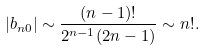Convert formula to latex. <formula><loc_0><loc_0><loc_500><loc_500>| b _ { n 0 } | \sim \frac { ( n - 1 ) ! } { 2 ^ { n - 1 } ( 2 n - 1 ) } \sim n ! .</formula> 